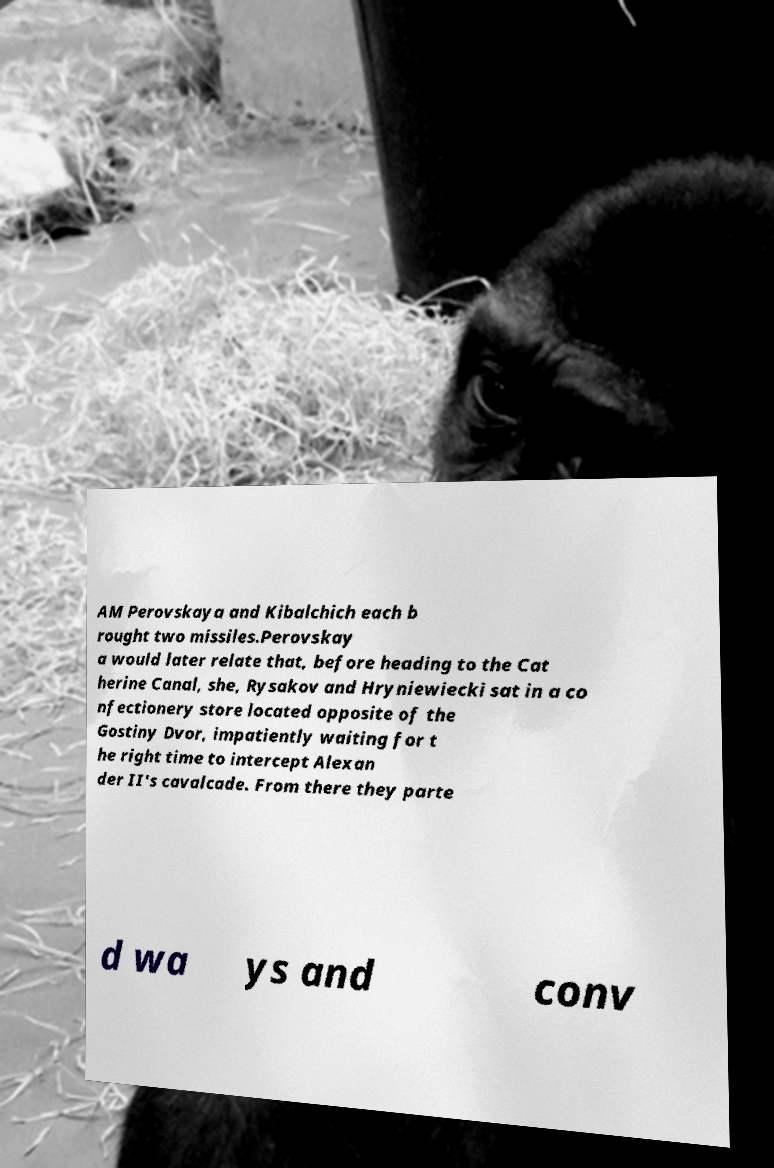Could you extract and type out the text from this image? AM Perovskaya and Kibalchich each b rought two missiles.Perovskay a would later relate that, before heading to the Cat herine Canal, she, Rysakov and Hryniewiecki sat in a co nfectionery store located opposite of the Gostiny Dvor, impatiently waiting for t he right time to intercept Alexan der II's cavalcade. From there they parte d wa ys and conv 